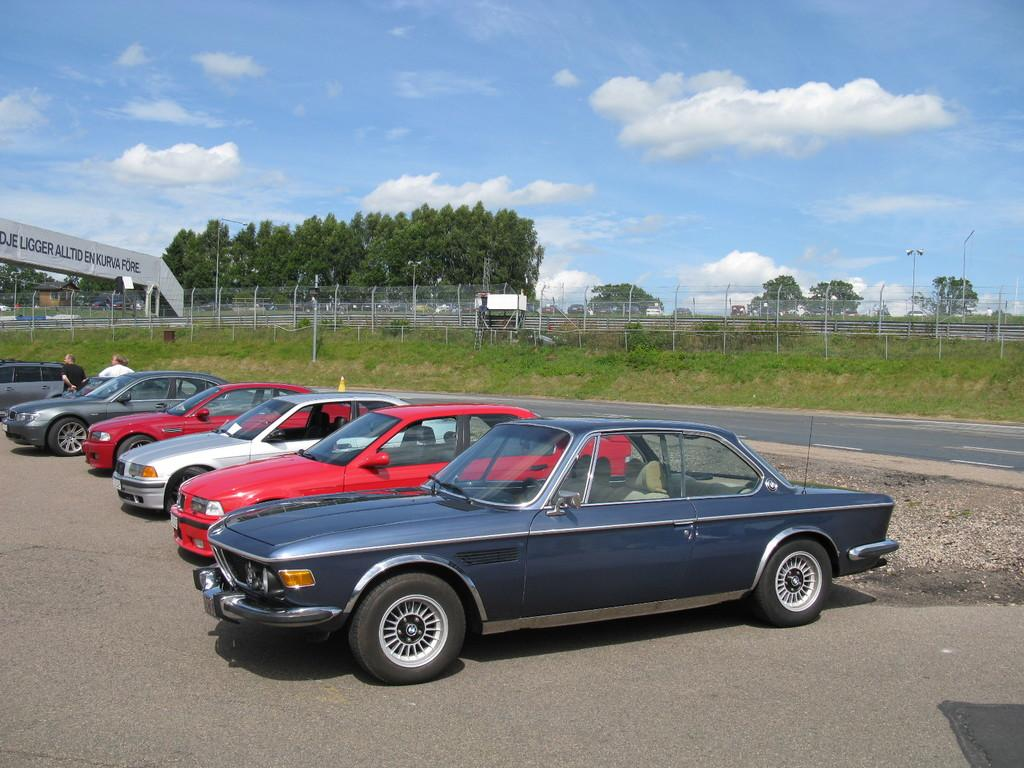What type of vehicles can be seen in the image? There are cars in the image. Who or what else is present in the image? There are people in the image. What can be seen in the background of the image? There is a hoarding, a fence, grass, trees, and clouds visible in the background of the image. How many toes can be seen on the cars in the image? Cars do not have toes, as they are vehicles and not living beings. 